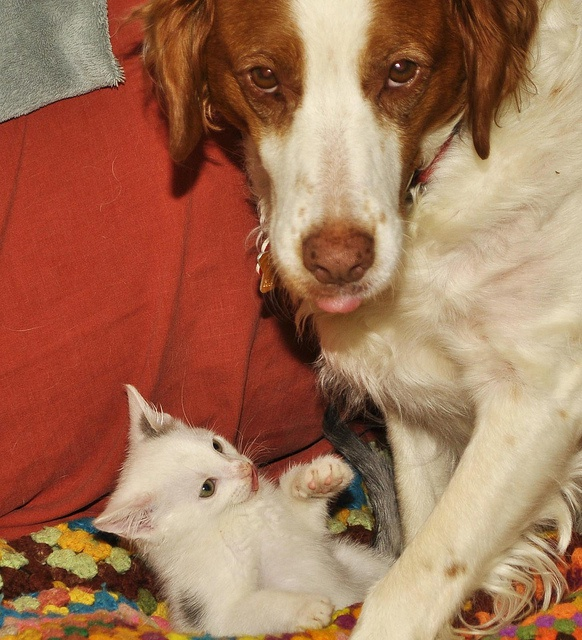Describe the objects in this image and their specific colors. I can see dog in gray, tan, and maroon tones, couch in gray, brown, maroon, and black tones, and cat in gray and tan tones in this image. 